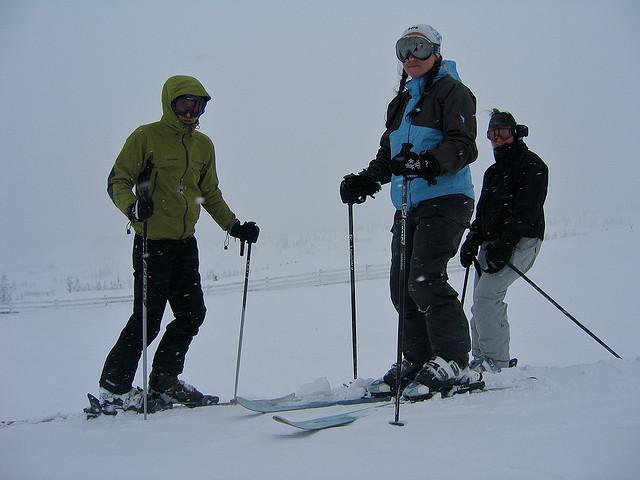How many people are in the picture?
Give a very brief answer. 3. How many ski poles are there?
Give a very brief answer. 6. How many people are visible?
Give a very brief answer. 3. How many of the baskets of food have forks in them?
Give a very brief answer. 0. 